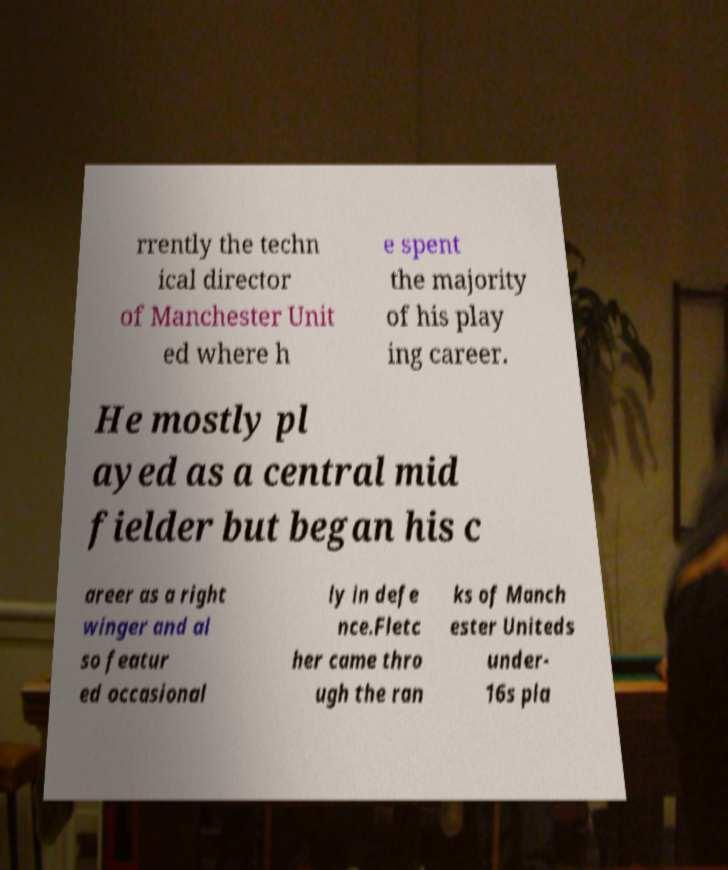Can you read and provide the text displayed in the image?This photo seems to have some interesting text. Can you extract and type it out for me? rrently the techn ical director of Manchester Unit ed where h e spent the majority of his play ing career. He mostly pl ayed as a central mid fielder but began his c areer as a right winger and al so featur ed occasional ly in defe nce.Fletc her came thro ugh the ran ks of Manch ester Uniteds under- 16s pla 